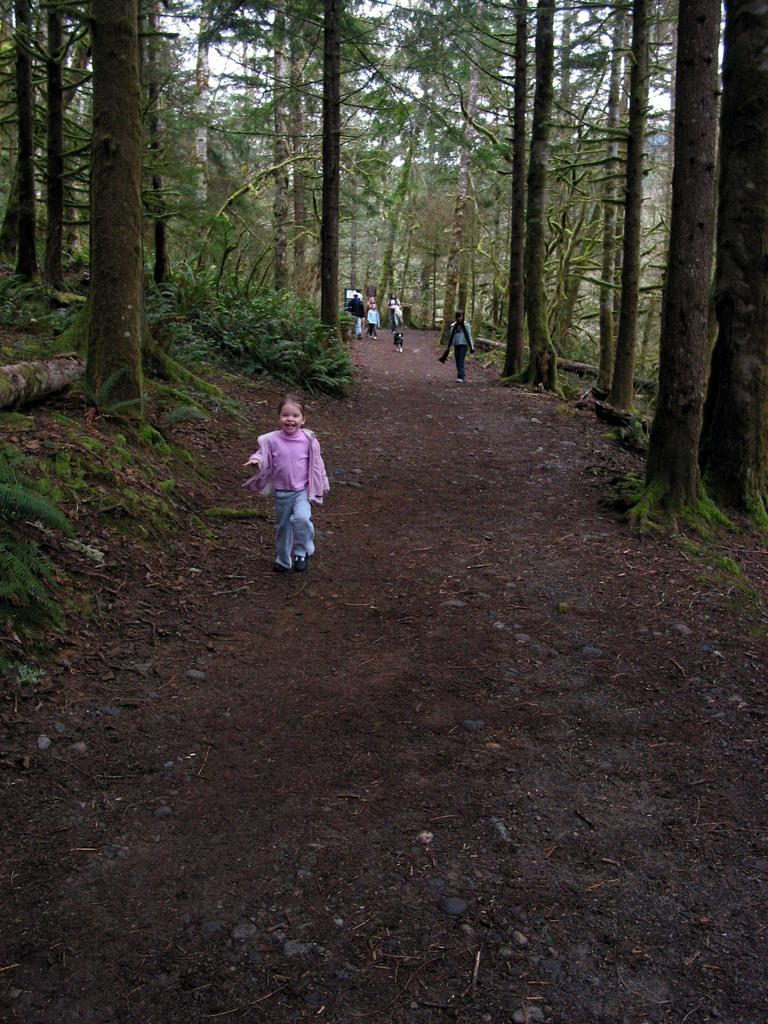What is happening in the image? There are people on a walkway in the image. Can you describe the people in the image? There are children in the image. What else is present in the image besides people? There is an animal and trees in the image. Can you tell me how many mice are swimming in the image? There are no mice present in the image, and they are not swimming. What type of pipe can be seen in the image? There is no pipe visible in the image. 